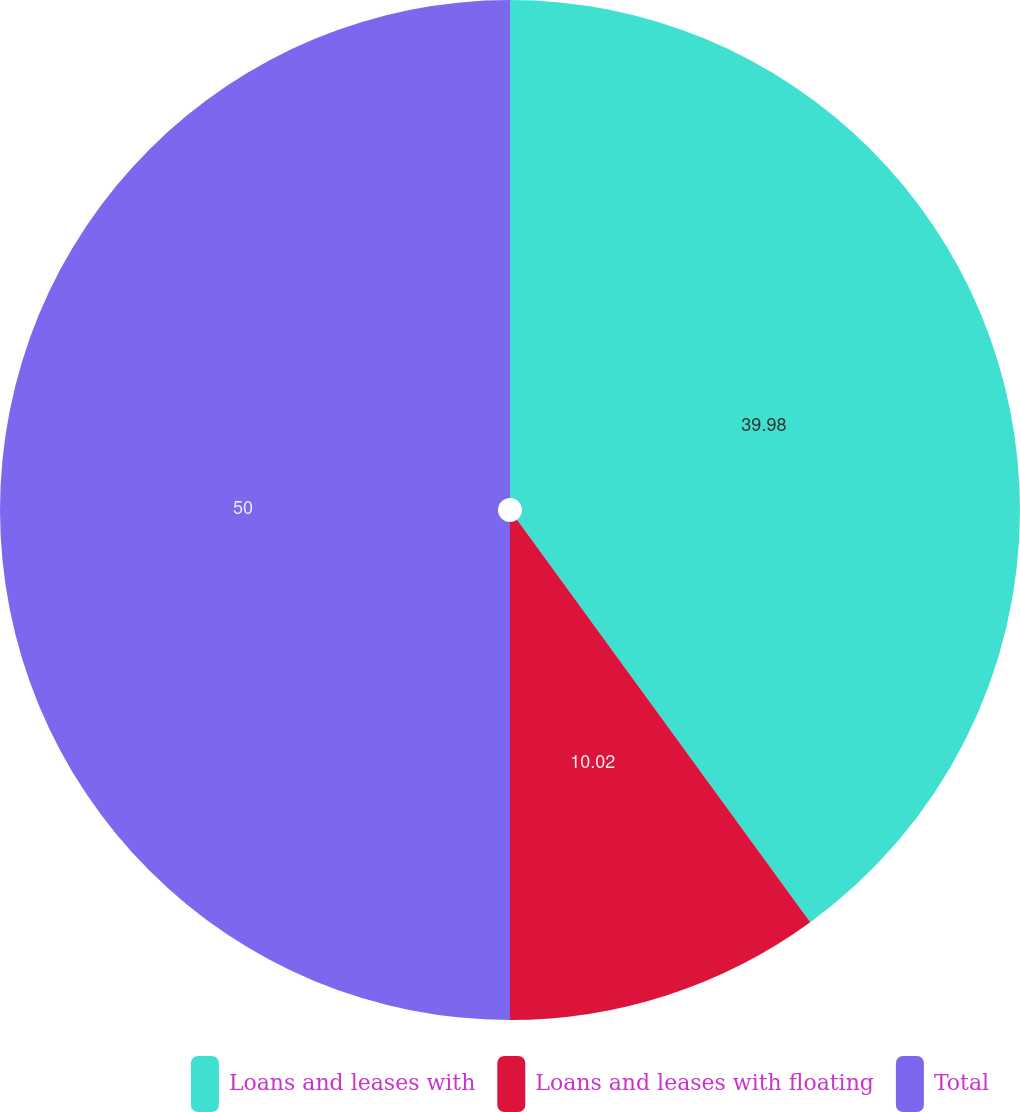<chart> <loc_0><loc_0><loc_500><loc_500><pie_chart><fcel>Loans and leases with<fcel>Loans and leases with floating<fcel>Total<nl><fcel>39.98%<fcel>10.02%<fcel>50.0%<nl></chart> 